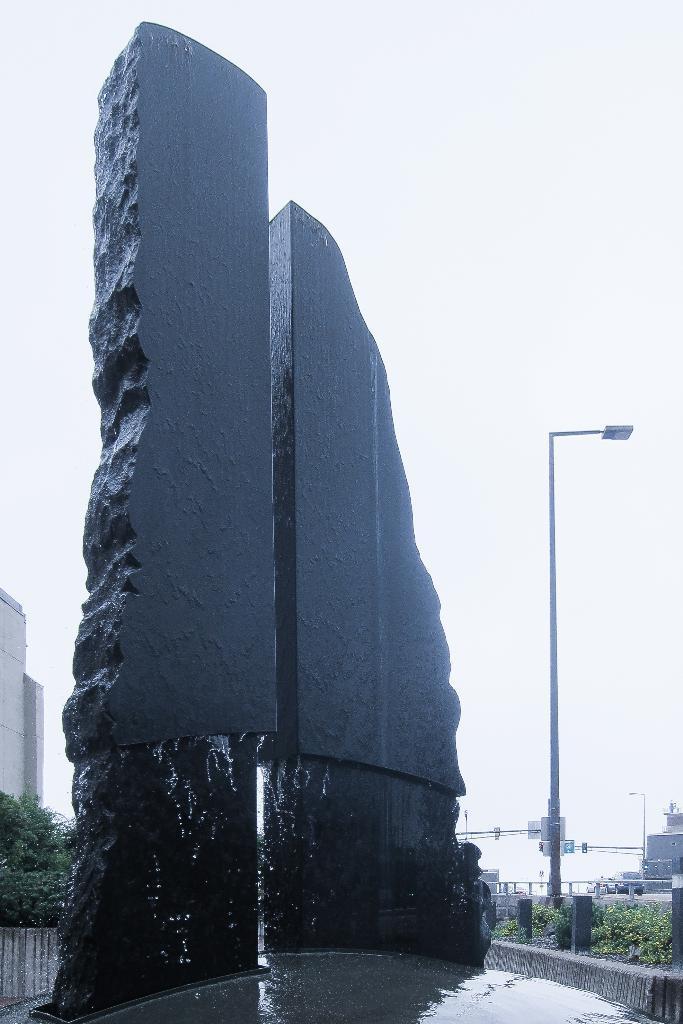Please provide a concise description of this image. This image consists of a tall rock. On the right, there are plants and a pole. On the left, we can see a building. At the top, there is sky. 